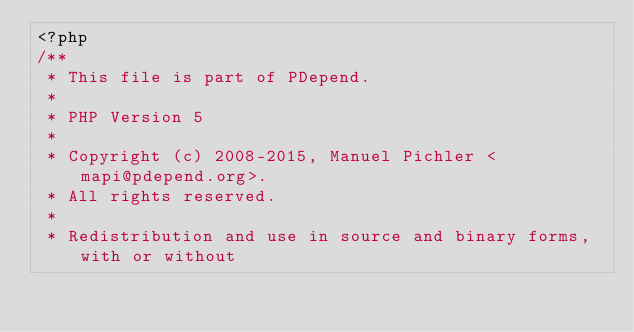<code> <loc_0><loc_0><loc_500><loc_500><_PHP_><?php
/**
 * This file is part of PDepend.
 *
 * PHP Version 5
 *
 * Copyright (c) 2008-2015, Manuel Pichler <mapi@pdepend.org>.
 * All rights reserved.
 *
 * Redistribution and use in source and binary forms, with or without</code> 